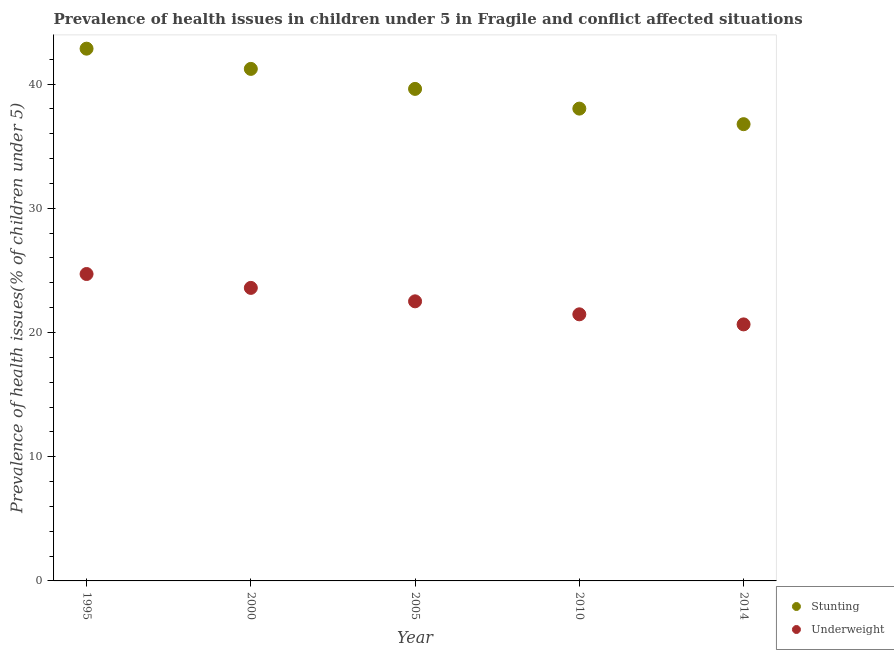What is the percentage of stunted children in 2014?
Provide a short and direct response. 36.77. Across all years, what is the maximum percentage of stunted children?
Ensure brevity in your answer.  42.85. Across all years, what is the minimum percentage of stunted children?
Your answer should be compact. 36.77. What is the total percentage of underweight children in the graph?
Keep it short and to the point. 112.92. What is the difference between the percentage of underweight children in 1995 and that in 2005?
Your response must be concise. 2.2. What is the difference between the percentage of stunted children in 2014 and the percentage of underweight children in 2005?
Provide a short and direct response. 14.26. What is the average percentage of underweight children per year?
Offer a very short reply. 22.58. In the year 1995, what is the difference between the percentage of underweight children and percentage of stunted children?
Offer a very short reply. -18.14. In how many years, is the percentage of underweight children greater than 4 %?
Give a very brief answer. 5. What is the ratio of the percentage of underweight children in 2000 to that in 2005?
Your answer should be very brief. 1.05. Is the difference between the percentage of stunted children in 1995 and 2010 greater than the difference between the percentage of underweight children in 1995 and 2010?
Make the answer very short. Yes. What is the difference between the highest and the second highest percentage of stunted children?
Make the answer very short. 1.63. What is the difference between the highest and the lowest percentage of underweight children?
Provide a short and direct response. 4.06. In how many years, is the percentage of stunted children greater than the average percentage of stunted children taken over all years?
Offer a very short reply. 2. Is the sum of the percentage of underweight children in 1995 and 2000 greater than the maximum percentage of stunted children across all years?
Give a very brief answer. Yes. Does the percentage of stunted children monotonically increase over the years?
Give a very brief answer. No. What is the difference between two consecutive major ticks on the Y-axis?
Provide a succinct answer. 10. Where does the legend appear in the graph?
Make the answer very short. Bottom right. How many legend labels are there?
Provide a short and direct response. 2. How are the legend labels stacked?
Your response must be concise. Vertical. What is the title of the graph?
Offer a terse response. Prevalence of health issues in children under 5 in Fragile and conflict affected situations. Does "Pregnant women" appear as one of the legend labels in the graph?
Your answer should be compact. No. What is the label or title of the Y-axis?
Give a very brief answer. Prevalence of health issues(% of children under 5). What is the Prevalence of health issues(% of children under 5) in Stunting in 1995?
Your response must be concise. 42.85. What is the Prevalence of health issues(% of children under 5) in Underweight in 1995?
Provide a short and direct response. 24.71. What is the Prevalence of health issues(% of children under 5) of Stunting in 2000?
Provide a succinct answer. 41.22. What is the Prevalence of health issues(% of children under 5) of Underweight in 2000?
Make the answer very short. 23.59. What is the Prevalence of health issues(% of children under 5) of Stunting in 2005?
Your answer should be compact. 39.61. What is the Prevalence of health issues(% of children under 5) of Underweight in 2005?
Offer a terse response. 22.51. What is the Prevalence of health issues(% of children under 5) in Stunting in 2010?
Make the answer very short. 38.02. What is the Prevalence of health issues(% of children under 5) in Underweight in 2010?
Ensure brevity in your answer.  21.46. What is the Prevalence of health issues(% of children under 5) of Stunting in 2014?
Your response must be concise. 36.77. What is the Prevalence of health issues(% of children under 5) of Underweight in 2014?
Provide a succinct answer. 20.65. Across all years, what is the maximum Prevalence of health issues(% of children under 5) in Stunting?
Provide a short and direct response. 42.85. Across all years, what is the maximum Prevalence of health issues(% of children under 5) in Underweight?
Give a very brief answer. 24.71. Across all years, what is the minimum Prevalence of health issues(% of children under 5) in Stunting?
Offer a terse response. 36.77. Across all years, what is the minimum Prevalence of health issues(% of children under 5) in Underweight?
Your answer should be very brief. 20.65. What is the total Prevalence of health issues(% of children under 5) in Stunting in the graph?
Give a very brief answer. 198.48. What is the total Prevalence of health issues(% of children under 5) in Underweight in the graph?
Offer a terse response. 112.92. What is the difference between the Prevalence of health issues(% of children under 5) in Stunting in 1995 and that in 2000?
Your answer should be compact. 1.63. What is the difference between the Prevalence of health issues(% of children under 5) of Underweight in 1995 and that in 2000?
Provide a succinct answer. 1.12. What is the difference between the Prevalence of health issues(% of children under 5) in Stunting in 1995 and that in 2005?
Keep it short and to the point. 3.24. What is the difference between the Prevalence of health issues(% of children under 5) of Underweight in 1995 and that in 2005?
Provide a short and direct response. 2.2. What is the difference between the Prevalence of health issues(% of children under 5) in Stunting in 1995 and that in 2010?
Ensure brevity in your answer.  4.83. What is the difference between the Prevalence of health issues(% of children under 5) in Underweight in 1995 and that in 2010?
Give a very brief answer. 3.25. What is the difference between the Prevalence of health issues(% of children under 5) in Stunting in 1995 and that in 2014?
Keep it short and to the point. 6.08. What is the difference between the Prevalence of health issues(% of children under 5) in Underweight in 1995 and that in 2014?
Offer a very short reply. 4.06. What is the difference between the Prevalence of health issues(% of children under 5) in Stunting in 2000 and that in 2005?
Offer a very short reply. 1.61. What is the difference between the Prevalence of health issues(% of children under 5) of Underweight in 2000 and that in 2005?
Offer a very short reply. 1.08. What is the difference between the Prevalence of health issues(% of children under 5) of Stunting in 2000 and that in 2010?
Offer a very short reply. 3.2. What is the difference between the Prevalence of health issues(% of children under 5) in Underweight in 2000 and that in 2010?
Provide a short and direct response. 2.13. What is the difference between the Prevalence of health issues(% of children under 5) in Stunting in 2000 and that in 2014?
Your answer should be compact. 4.45. What is the difference between the Prevalence of health issues(% of children under 5) of Underweight in 2000 and that in 2014?
Keep it short and to the point. 2.94. What is the difference between the Prevalence of health issues(% of children under 5) of Stunting in 2005 and that in 2010?
Offer a very short reply. 1.59. What is the difference between the Prevalence of health issues(% of children under 5) of Underweight in 2005 and that in 2010?
Provide a short and direct response. 1.05. What is the difference between the Prevalence of health issues(% of children under 5) in Stunting in 2005 and that in 2014?
Make the answer very short. 2.84. What is the difference between the Prevalence of health issues(% of children under 5) of Underweight in 2005 and that in 2014?
Your answer should be very brief. 1.86. What is the difference between the Prevalence of health issues(% of children under 5) in Stunting in 2010 and that in 2014?
Offer a very short reply. 1.25. What is the difference between the Prevalence of health issues(% of children under 5) of Underweight in 2010 and that in 2014?
Provide a short and direct response. 0.81. What is the difference between the Prevalence of health issues(% of children under 5) in Stunting in 1995 and the Prevalence of health issues(% of children under 5) in Underweight in 2000?
Your answer should be very brief. 19.26. What is the difference between the Prevalence of health issues(% of children under 5) of Stunting in 1995 and the Prevalence of health issues(% of children under 5) of Underweight in 2005?
Your answer should be compact. 20.34. What is the difference between the Prevalence of health issues(% of children under 5) in Stunting in 1995 and the Prevalence of health issues(% of children under 5) in Underweight in 2010?
Give a very brief answer. 21.39. What is the difference between the Prevalence of health issues(% of children under 5) of Stunting in 1995 and the Prevalence of health issues(% of children under 5) of Underweight in 2014?
Give a very brief answer. 22.2. What is the difference between the Prevalence of health issues(% of children under 5) in Stunting in 2000 and the Prevalence of health issues(% of children under 5) in Underweight in 2005?
Your answer should be compact. 18.71. What is the difference between the Prevalence of health issues(% of children under 5) in Stunting in 2000 and the Prevalence of health issues(% of children under 5) in Underweight in 2010?
Provide a succinct answer. 19.76. What is the difference between the Prevalence of health issues(% of children under 5) of Stunting in 2000 and the Prevalence of health issues(% of children under 5) of Underweight in 2014?
Provide a succinct answer. 20.57. What is the difference between the Prevalence of health issues(% of children under 5) of Stunting in 2005 and the Prevalence of health issues(% of children under 5) of Underweight in 2010?
Provide a succinct answer. 18.15. What is the difference between the Prevalence of health issues(% of children under 5) in Stunting in 2005 and the Prevalence of health issues(% of children under 5) in Underweight in 2014?
Your response must be concise. 18.96. What is the difference between the Prevalence of health issues(% of children under 5) in Stunting in 2010 and the Prevalence of health issues(% of children under 5) in Underweight in 2014?
Offer a terse response. 17.37. What is the average Prevalence of health issues(% of children under 5) of Stunting per year?
Offer a terse response. 39.7. What is the average Prevalence of health issues(% of children under 5) in Underweight per year?
Your answer should be very brief. 22.58. In the year 1995, what is the difference between the Prevalence of health issues(% of children under 5) of Stunting and Prevalence of health issues(% of children under 5) of Underweight?
Your answer should be compact. 18.14. In the year 2000, what is the difference between the Prevalence of health issues(% of children under 5) in Stunting and Prevalence of health issues(% of children under 5) in Underweight?
Make the answer very short. 17.63. In the year 2005, what is the difference between the Prevalence of health issues(% of children under 5) in Stunting and Prevalence of health issues(% of children under 5) in Underweight?
Your answer should be compact. 17.1. In the year 2010, what is the difference between the Prevalence of health issues(% of children under 5) in Stunting and Prevalence of health issues(% of children under 5) in Underweight?
Offer a terse response. 16.56. In the year 2014, what is the difference between the Prevalence of health issues(% of children under 5) of Stunting and Prevalence of health issues(% of children under 5) of Underweight?
Your answer should be very brief. 16.12. What is the ratio of the Prevalence of health issues(% of children under 5) in Stunting in 1995 to that in 2000?
Give a very brief answer. 1.04. What is the ratio of the Prevalence of health issues(% of children under 5) in Underweight in 1995 to that in 2000?
Provide a short and direct response. 1.05. What is the ratio of the Prevalence of health issues(% of children under 5) of Stunting in 1995 to that in 2005?
Offer a terse response. 1.08. What is the ratio of the Prevalence of health issues(% of children under 5) in Underweight in 1995 to that in 2005?
Your response must be concise. 1.1. What is the ratio of the Prevalence of health issues(% of children under 5) in Stunting in 1995 to that in 2010?
Ensure brevity in your answer.  1.13. What is the ratio of the Prevalence of health issues(% of children under 5) in Underweight in 1995 to that in 2010?
Your answer should be very brief. 1.15. What is the ratio of the Prevalence of health issues(% of children under 5) in Stunting in 1995 to that in 2014?
Offer a very short reply. 1.17. What is the ratio of the Prevalence of health issues(% of children under 5) in Underweight in 1995 to that in 2014?
Provide a succinct answer. 1.2. What is the ratio of the Prevalence of health issues(% of children under 5) of Stunting in 2000 to that in 2005?
Make the answer very short. 1.04. What is the ratio of the Prevalence of health issues(% of children under 5) in Underweight in 2000 to that in 2005?
Your answer should be compact. 1.05. What is the ratio of the Prevalence of health issues(% of children under 5) in Stunting in 2000 to that in 2010?
Provide a short and direct response. 1.08. What is the ratio of the Prevalence of health issues(% of children under 5) in Underweight in 2000 to that in 2010?
Provide a succinct answer. 1.1. What is the ratio of the Prevalence of health issues(% of children under 5) of Stunting in 2000 to that in 2014?
Offer a terse response. 1.12. What is the ratio of the Prevalence of health issues(% of children under 5) in Underweight in 2000 to that in 2014?
Your answer should be compact. 1.14. What is the ratio of the Prevalence of health issues(% of children under 5) of Stunting in 2005 to that in 2010?
Provide a short and direct response. 1.04. What is the ratio of the Prevalence of health issues(% of children under 5) of Underweight in 2005 to that in 2010?
Offer a terse response. 1.05. What is the ratio of the Prevalence of health issues(% of children under 5) of Stunting in 2005 to that in 2014?
Ensure brevity in your answer.  1.08. What is the ratio of the Prevalence of health issues(% of children under 5) in Underweight in 2005 to that in 2014?
Offer a terse response. 1.09. What is the ratio of the Prevalence of health issues(% of children under 5) of Stunting in 2010 to that in 2014?
Provide a short and direct response. 1.03. What is the ratio of the Prevalence of health issues(% of children under 5) of Underweight in 2010 to that in 2014?
Your answer should be compact. 1.04. What is the difference between the highest and the second highest Prevalence of health issues(% of children under 5) in Stunting?
Provide a short and direct response. 1.63. What is the difference between the highest and the second highest Prevalence of health issues(% of children under 5) of Underweight?
Your response must be concise. 1.12. What is the difference between the highest and the lowest Prevalence of health issues(% of children under 5) of Stunting?
Provide a succinct answer. 6.08. What is the difference between the highest and the lowest Prevalence of health issues(% of children under 5) in Underweight?
Make the answer very short. 4.06. 